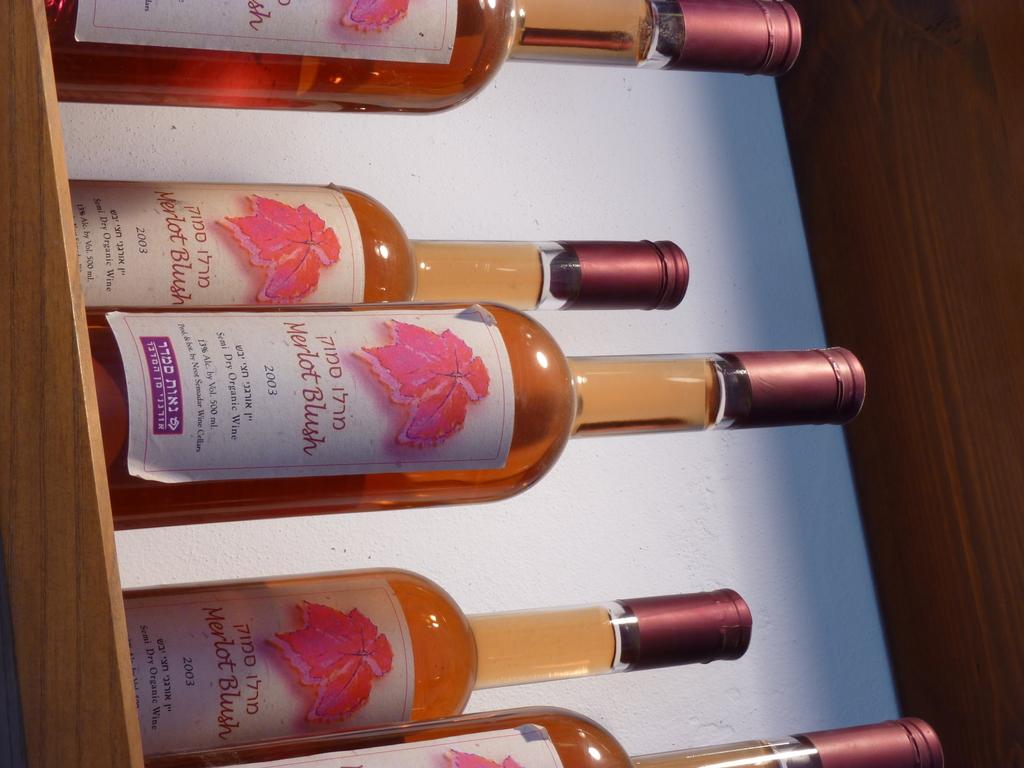What year is written on the wine?
Give a very brief answer. 2003. 